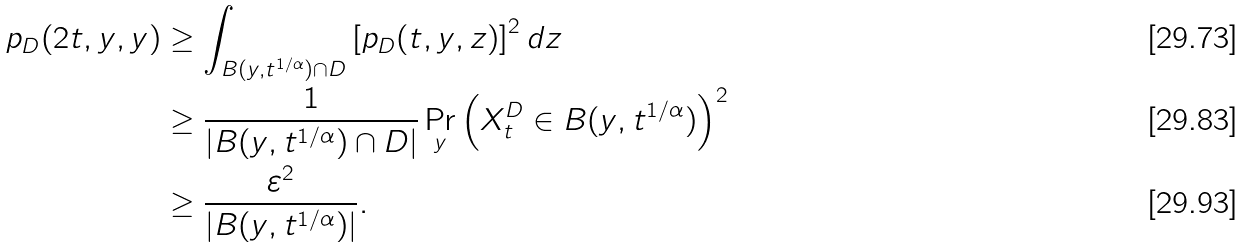Convert formula to latex. <formula><loc_0><loc_0><loc_500><loc_500>p _ { D } ( 2 t , y , y ) & \geq \int _ { B ( y , t ^ { 1 / \alpha } ) \cap D } \left [ p _ { D } ( t , y , z ) \right ] ^ { 2 } d z \\ & \geq \frac { 1 } { | B ( y , t ^ { 1 / \alpha } ) \cap D | } \Pr _ { y } \left ( X _ { t } ^ { D } \in B ( y , t ^ { 1 / \alpha } ) \right ) ^ { 2 } \\ & \geq \frac { \varepsilon ^ { 2 } } { | B ( y , t ^ { 1 / \alpha } ) | } .</formula> 